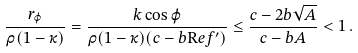Convert formula to latex. <formula><loc_0><loc_0><loc_500><loc_500>\frac { r _ { \varphi } } { \rho ( 1 - \kappa ) } = \frac { k \cos \varphi } { \rho ( 1 - \kappa ) ( c - b { \mathrm R e } f ^ { \prime } ) } \leq \frac { c - 2 b \sqrt { A } } { c - b A } < 1 \, .</formula> 